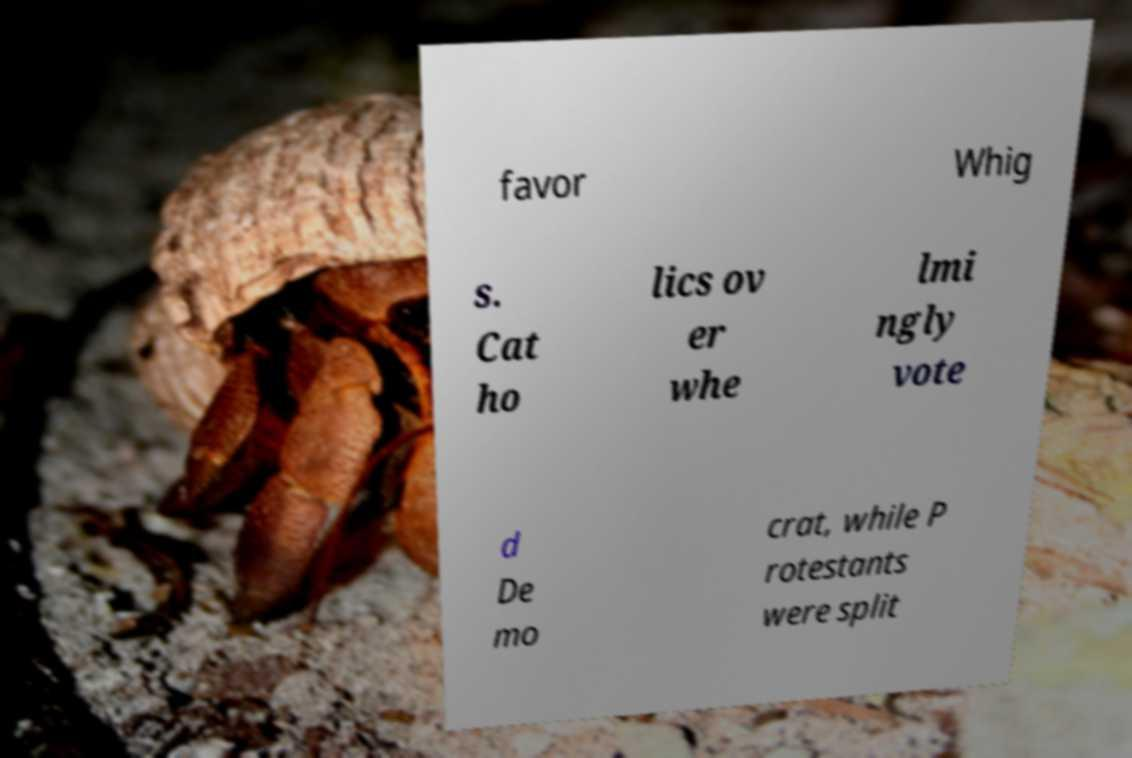There's text embedded in this image that I need extracted. Can you transcribe it verbatim? favor Whig s. Cat ho lics ov er whe lmi ngly vote d De mo crat, while P rotestants were split 